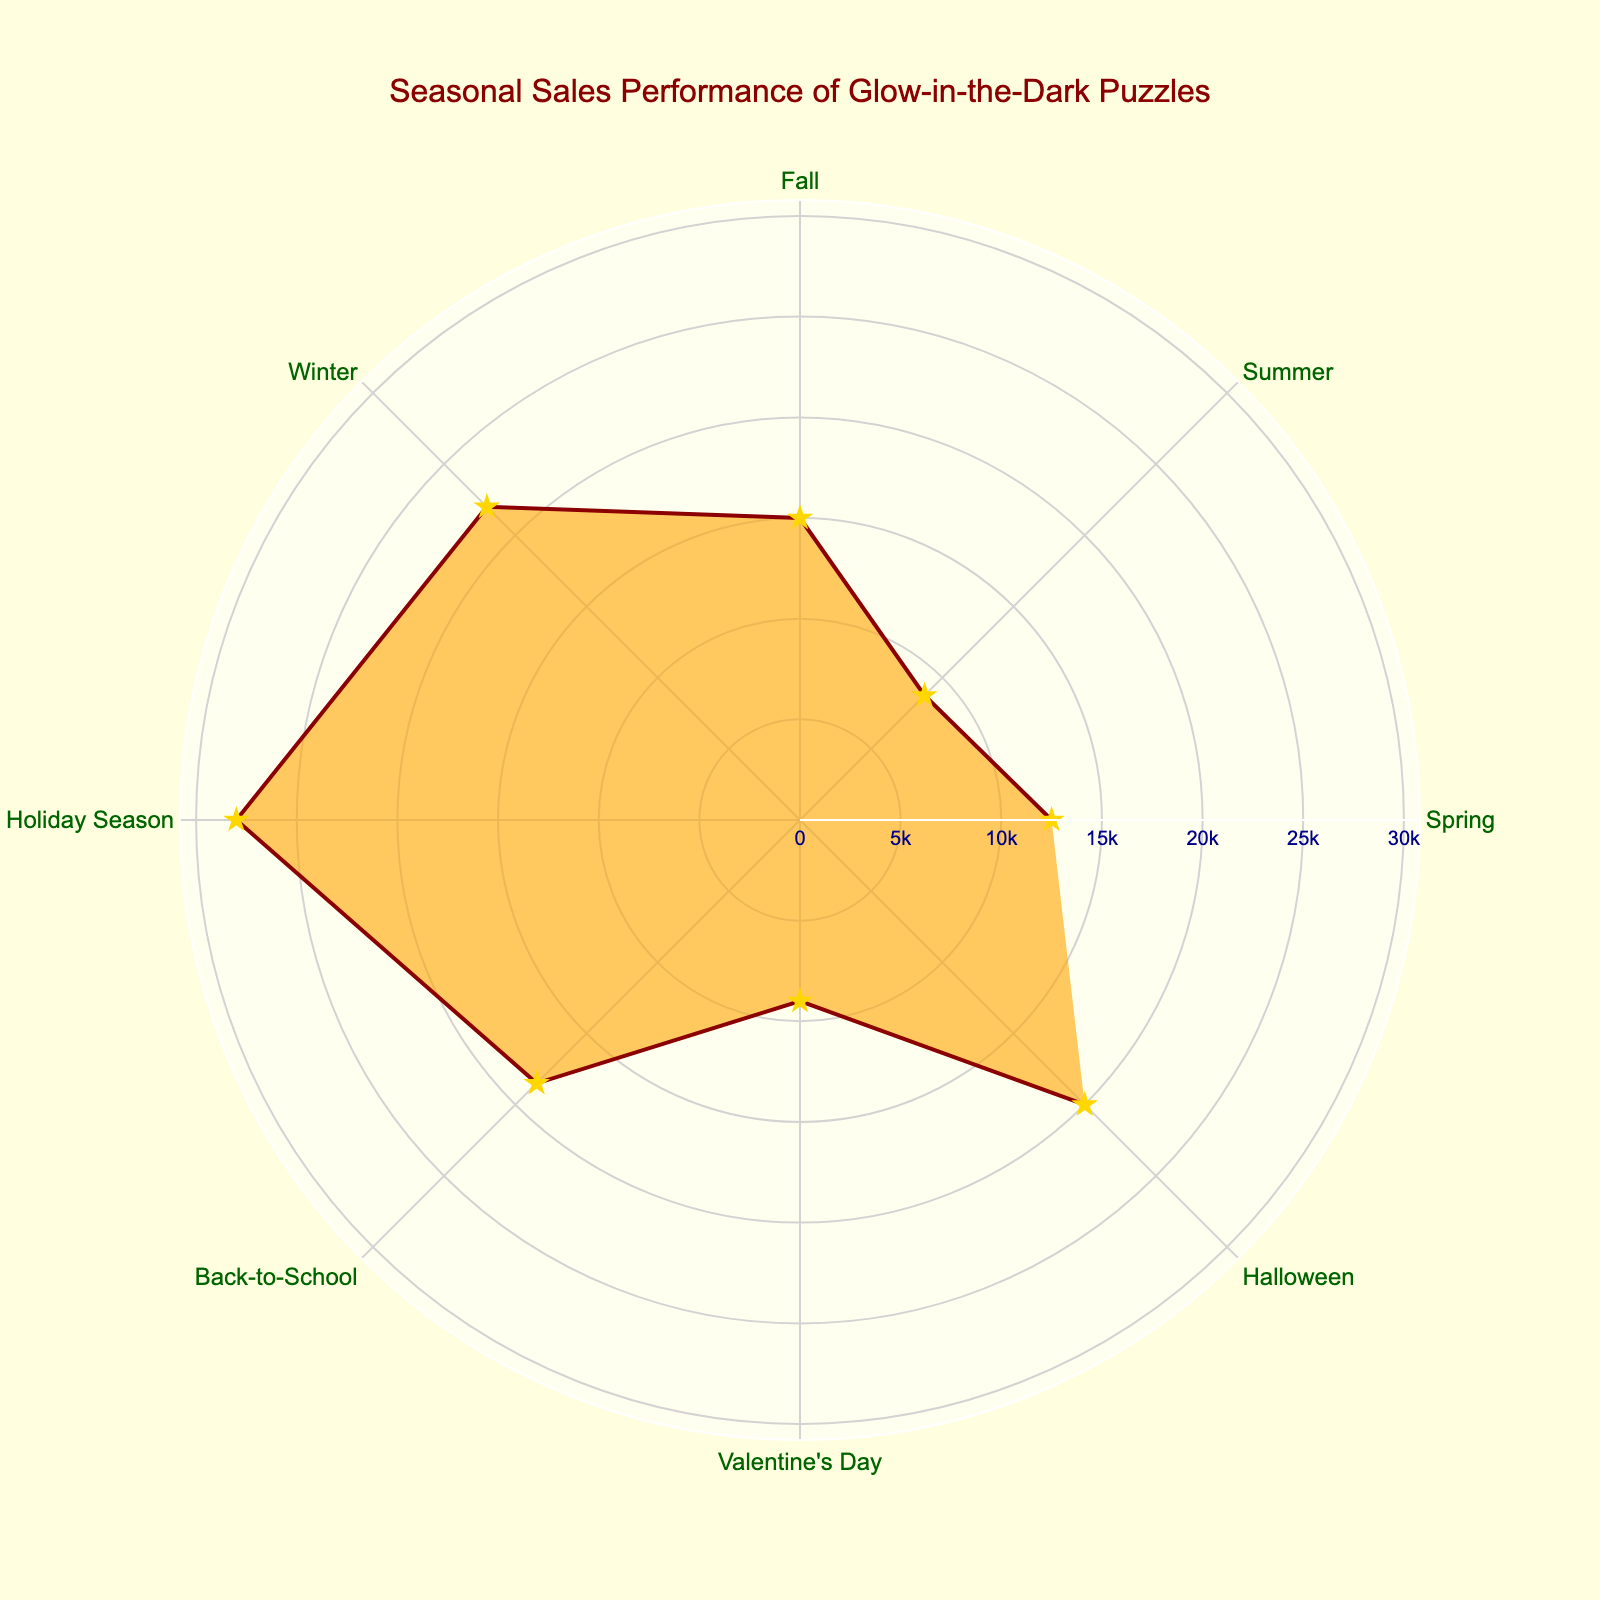What's the title of the chart? To find the title, look at the top center area of the chart where the title text is displayed.
Answer: Seasonal Sales Performance of Glow-in-the-Dark Puzzles Which season had the highest sales? To determine the season with the highest sales, look for the longest radial distance extending from the center of the chart. The label associated with this longest radius will indicate the season.
Answer: Holiday Season What is the total sales of glow-in-the-dark puzzles during "Spring" and "Summer"? To find the total, add the sales units for "Spring" (12,500) and "Summer" (8,750). The sum of these two values will give the total for these seasons.
Answer: 21,250 How do the sales in "Winter" compare to "Back-to-School"? Compare the radial lengths for "Winter" and "Back-to-School". "Winter" has a longer radius than "Back-to-School", indicating higher sales in winter.
Answer: Winter has higher sales than Back-to-School Which season has the lowest sales? Locate the shortest radial distance from the center outwards and check the associated label for that season.
Answer: Summer What is the difference in sales between "Halloween" and "Valentine's Day"? To find the difference, subtract the sales for "Valentine's Day" (9,000) from the sales for "Halloween" (20,000). The difference between these two values gives the result.
Answer: 11,000 What colors are used for the chart’s background and fill areas? Observe the colors used in the chart's background and the area inside the polar plot’s filled region. The background is light yellow, and the filled area is an orange shade with 60% opacity.
Answer: light yellow (background), translucent orange (fill) How many different seasons are plotted on the chart? Count the number of distinct labels around the circle of the polar chart to determine the number of seasons.
Answer: 8 Which seasons have sales units above 20,000? Observe the radial distance of each season. If the distance goes beyond the 20,000 units mark, those seasons have sales above 20,000 units.
Answer: Winter, Holiday Season, Halloween What is the average sales for "Fall" and "Back-to-School"? First, add the sales for "Fall" (15,000) and "Back-to-School" (18,500). Then divide the total by 2 to get the average.
Answer: 16,750 